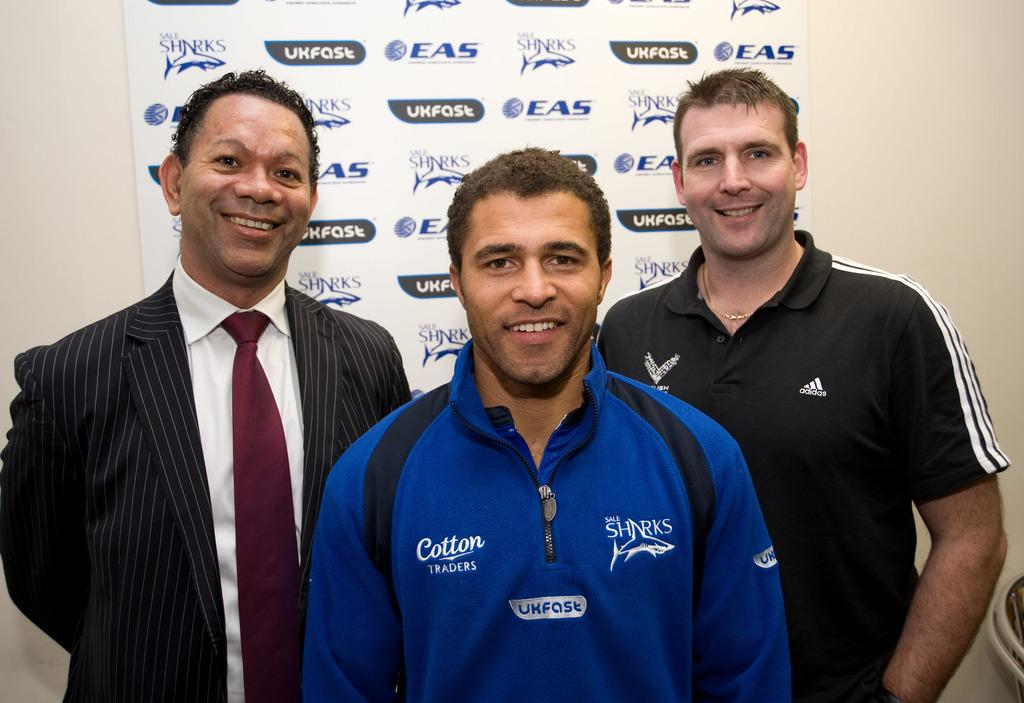<image>
Share a concise interpretation of the image provided. a jacket with the word Cotton on the front 